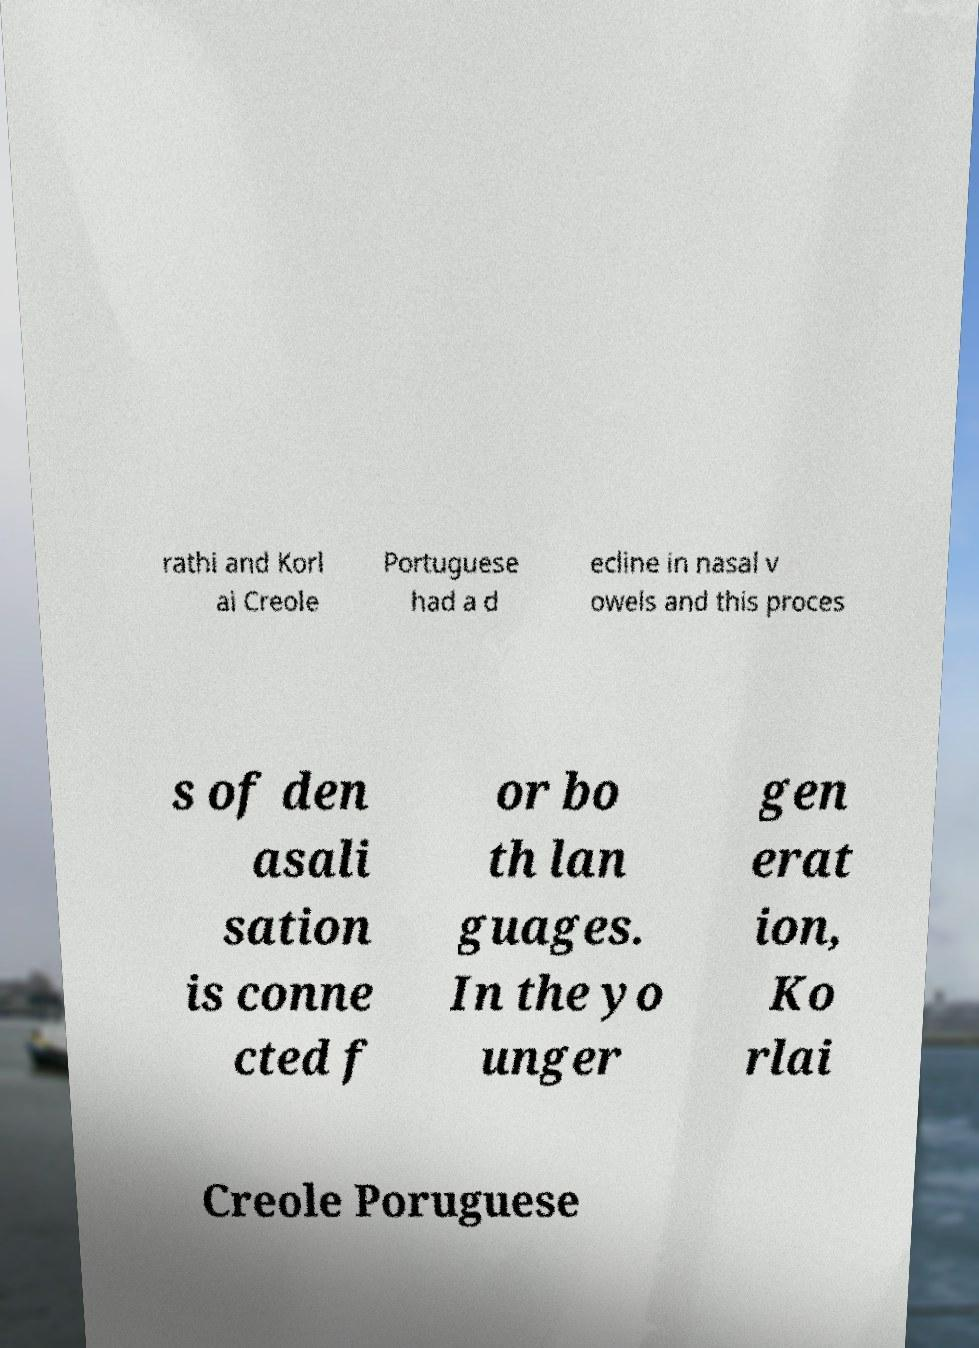Can you accurately transcribe the text from the provided image for me? rathi and Korl ai Creole Portuguese had a d ecline in nasal v owels and this proces s of den asali sation is conne cted f or bo th lan guages. In the yo unger gen erat ion, Ko rlai Creole Poruguese 